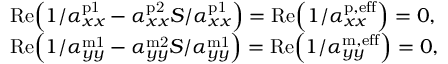Convert formula to latex. <formula><loc_0><loc_0><loc_500><loc_500>\begin{array} { r l } & { R e \left ( 1 / \alpha _ { x x } ^ { p 1 } - \alpha _ { x x } ^ { p 2 } S / \alpha _ { x x } ^ { p 1 } \right ) = R e \left ( 1 / \alpha _ { x x } ^ { p , e f f } \right ) = 0 , } \\ & { R e \left ( 1 / \alpha _ { y y } ^ { m 1 } - \alpha _ { y y } ^ { m 2 } S / \alpha _ { y y } ^ { m 1 } \right ) = R e \left ( 1 / \alpha _ { y y } ^ { m , e f f } \right ) = 0 , } \end{array}</formula> 